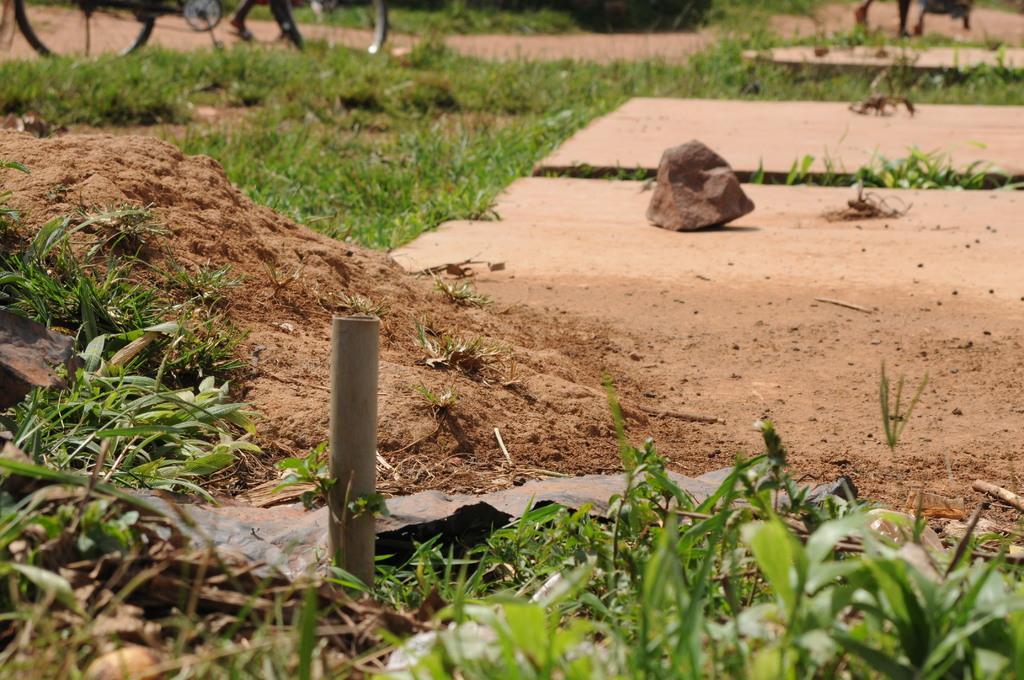In one or two sentences, can you explain what this image depicts? In this image I can see green grass,pole,rock and vehicles on the road. 